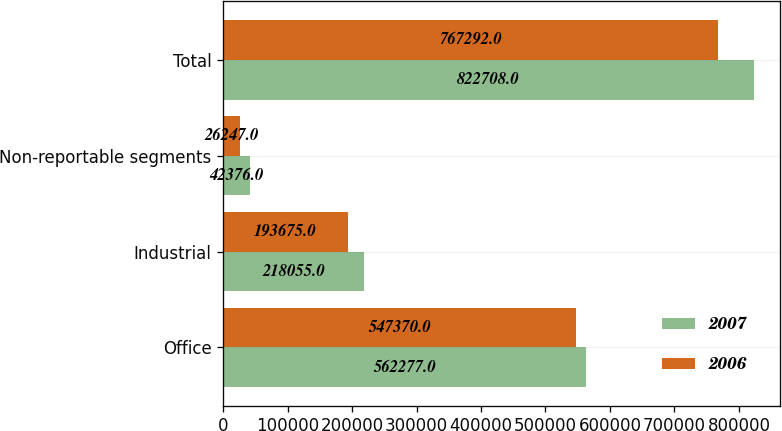<chart> <loc_0><loc_0><loc_500><loc_500><stacked_bar_chart><ecel><fcel>Office<fcel>Industrial<fcel>Non-reportable segments<fcel>Total<nl><fcel>2007<fcel>562277<fcel>218055<fcel>42376<fcel>822708<nl><fcel>2006<fcel>547370<fcel>193675<fcel>26247<fcel>767292<nl></chart> 